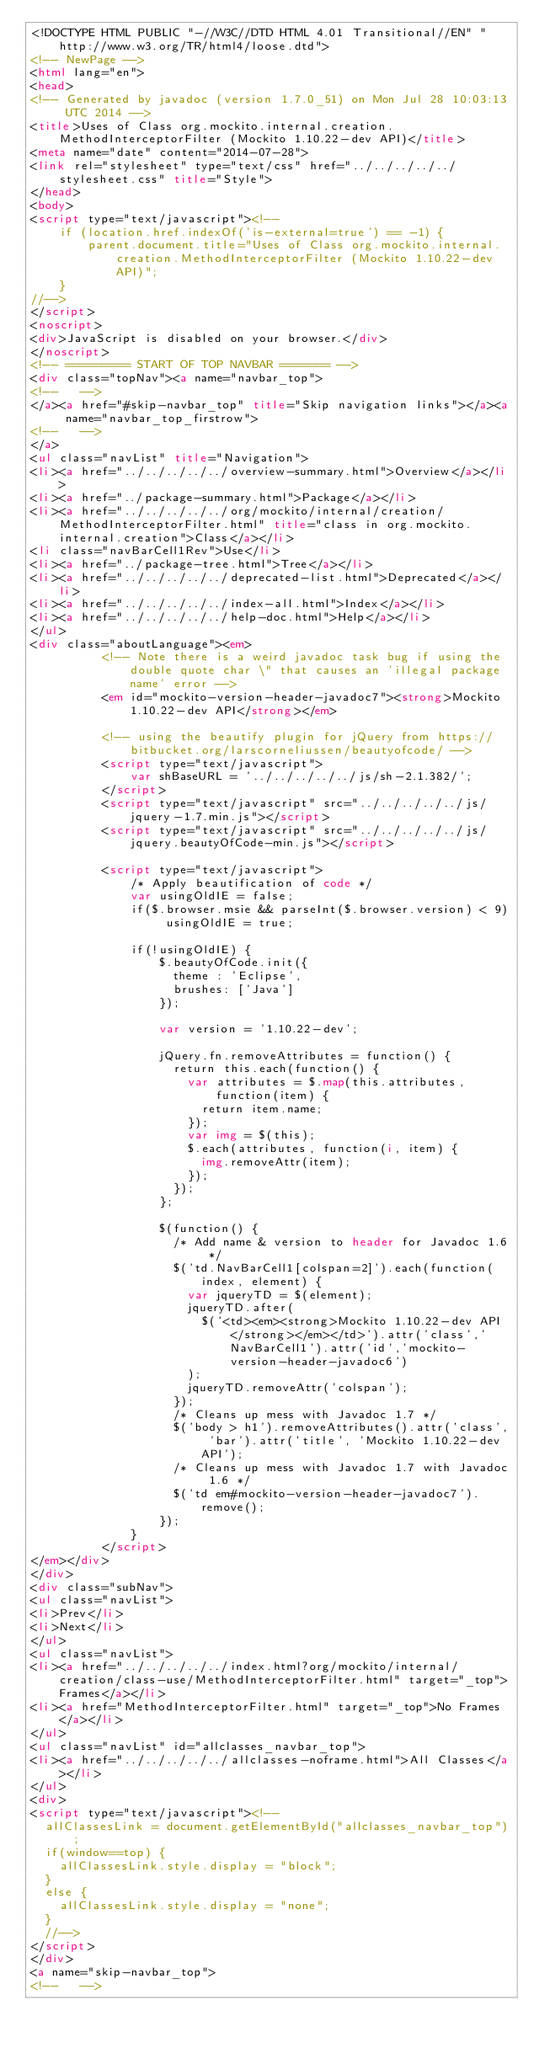<code> <loc_0><loc_0><loc_500><loc_500><_HTML_><!DOCTYPE HTML PUBLIC "-//W3C//DTD HTML 4.01 Transitional//EN" "http://www.w3.org/TR/html4/loose.dtd">
<!-- NewPage -->
<html lang="en">
<head>
<!-- Generated by javadoc (version 1.7.0_51) on Mon Jul 28 10:03:13 UTC 2014 -->
<title>Uses of Class org.mockito.internal.creation.MethodInterceptorFilter (Mockito 1.10.22-dev API)</title>
<meta name="date" content="2014-07-28">
<link rel="stylesheet" type="text/css" href="../../../../../stylesheet.css" title="Style">
</head>
<body>
<script type="text/javascript"><!--
    if (location.href.indexOf('is-external=true') == -1) {
        parent.document.title="Uses of Class org.mockito.internal.creation.MethodInterceptorFilter (Mockito 1.10.22-dev API)";
    }
//-->
</script>
<noscript>
<div>JavaScript is disabled on your browser.</div>
</noscript>
<!-- ========= START OF TOP NAVBAR ======= -->
<div class="topNav"><a name="navbar_top">
<!--   -->
</a><a href="#skip-navbar_top" title="Skip navigation links"></a><a name="navbar_top_firstrow">
<!--   -->
</a>
<ul class="navList" title="Navigation">
<li><a href="../../../../../overview-summary.html">Overview</a></li>
<li><a href="../package-summary.html">Package</a></li>
<li><a href="../../../../../org/mockito/internal/creation/MethodInterceptorFilter.html" title="class in org.mockito.internal.creation">Class</a></li>
<li class="navBarCell1Rev">Use</li>
<li><a href="../package-tree.html">Tree</a></li>
<li><a href="../../../../../deprecated-list.html">Deprecated</a></li>
<li><a href="../../../../../index-all.html">Index</a></li>
<li><a href="../../../../../help-doc.html">Help</a></li>
</ul>
<div class="aboutLanguage"><em>
          <!-- Note there is a weird javadoc task bug if using the double quote char \" that causes an 'illegal package name' error -->
          <em id="mockito-version-header-javadoc7"><strong>Mockito 1.10.22-dev API</strong></em>

          <!-- using the beautify plugin for jQuery from https://bitbucket.org/larscorneliussen/beautyofcode/ -->
          <script type="text/javascript">
              var shBaseURL = '../../../../../js/sh-2.1.382/';
          </script>
          <script type="text/javascript" src="../../../../../js/jquery-1.7.min.js"></script>
          <script type="text/javascript" src="../../../../../js/jquery.beautyOfCode-min.js"></script>

          <script type="text/javascript">
              /* Apply beautification of code */
              var usingOldIE = false;
              if($.browser.msie && parseInt($.browser.version) < 9) usingOldIE = true;

              if(!usingOldIE) {
                  $.beautyOfCode.init({
                    theme : 'Eclipse',
                    brushes: ['Java']
                  });

                  var version = '1.10.22-dev';

                  jQuery.fn.removeAttributes = function() {
                    return this.each(function() {
                      var attributes = $.map(this.attributes, function(item) {
                        return item.name;
                      });
                      var img = $(this);
                      $.each(attributes, function(i, item) {
                        img.removeAttr(item);
                      });
                    });
                  };

                  $(function() {
                    /* Add name & version to header for Javadoc 1.6 */
                    $('td.NavBarCell1[colspan=2]').each(function(index, element) {
                      var jqueryTD = $(element);
                      jqueryTD.after(
                        $('<td><em><strong>Mockito 1.10.22-dev API</strong></em></td>').attr('class','NavBarCell1').attr('id','mockito-version-header-javadoc6')
                      );
                      jqueryTD.removeAttr('colspan');
                    });
                    /* Cleans up mess with Javadoc 1.7 */
                    $('body > h1').removeAttributes().attr('class', 'bar').attr('title', 'Mockito 1.10.22-dev API');
                    /* Cleans up mess with Javadoc 1.7 with Javadoc 1.6 */
                    $('td em#mockito-version-header-javadoc7').remove();
                  });
              }
          </script>
</em></div>
</div>
<div class="subNav">
<ul class="navList">
<li>Prev</li>
<li>Next</li>
</ul>
<ul class="navList">
<li><a href="../../../../../index.html?org/mockito/internal/creation/class-use/MethodInterceptorFilter.html" target="_top">Frames</a></li>
<li><a href="MethodInterceptorFilter.html" target="_top">No Frames</a></li>
</ul>
<ul class="navList" id="allclasses_navbar_top">
<li><a href="../../../../../allclasses-noframe.html">All Classes</a></li>
</ul>
<div>
<script type="text/javascript"><!--
  allClassesLink = document.getElementById("allclasses_navbar_top");
  if(window==top) {
    allClassesLink.style.display = "block";
  }
  else {
    allClassesLink.style.display = "none";
  }
  //-->
</script>
</div>
<a name="skip-navbar_top">
<!--   --></code> 